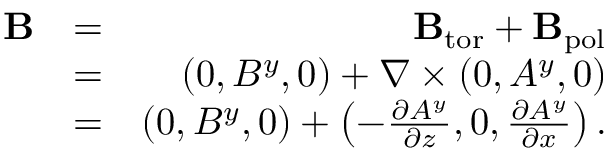<formula> <loc_0><loc_0><loc_500><loc_500>\begin{array} { r l r } { B } & { = } & { { B } _ { t o r } + { B } _ { p o l } } \\ & { = } & { ( 0 , B ^ { y } , 0 ) + \nabla \times \left ( { 0 , A ^ { y } , 0 } \right ) } \\ & { = } & { ( 0 , B ^ { y } , 0 ) + \left ( { - \frac { \partial A ^ { y } } { \partial z } , 0 , \frac { \partial A ^ { y } } { \partial x } } \right ) . } \end{array}</formula> 